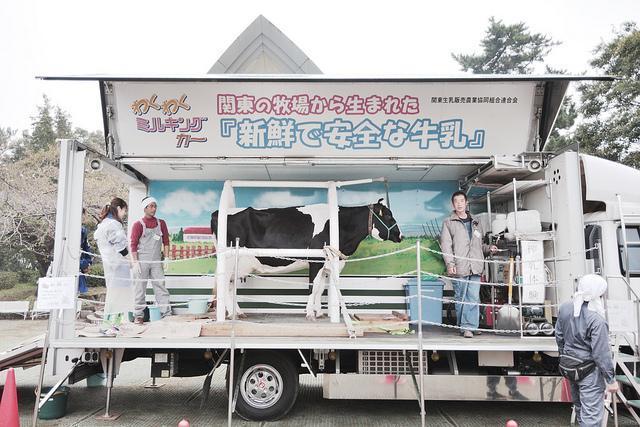How many people are in the picture?
Give a very brief answer. 4. 